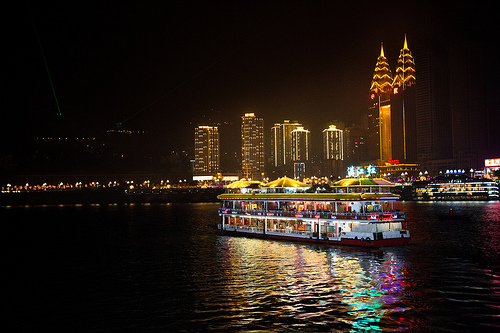What color is the umbrella on the right part? The umbrella on the right side of the image is yellow. 